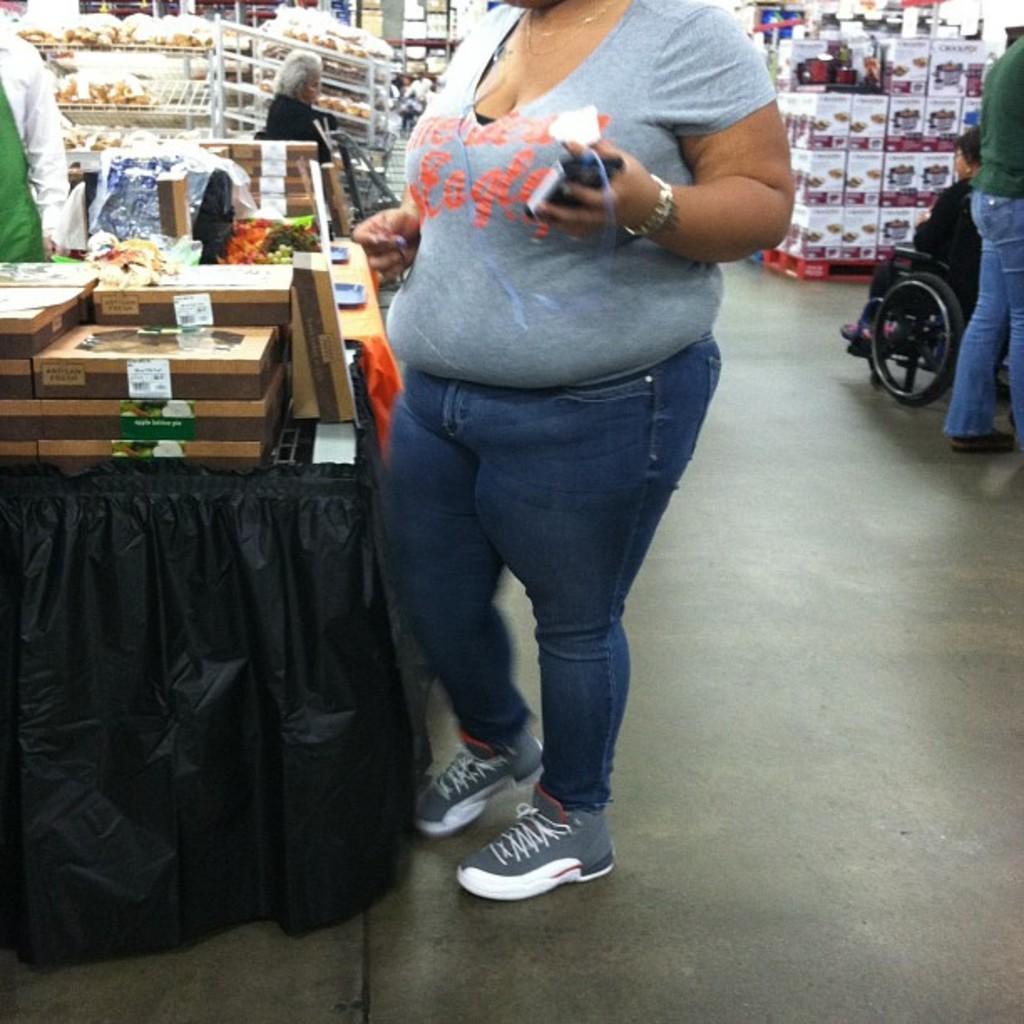How would you summarize this image in a sentence or two? In this image in the center there is one person standing, and she is holding something in her hands. And beside her there is one table, on the table there are some boxes and some objects. In the background there are some boxes and some other objects, and also there are some people. On the right side of the image there is one person who is sitting on wheelchair, and at the bottom there is floor. 